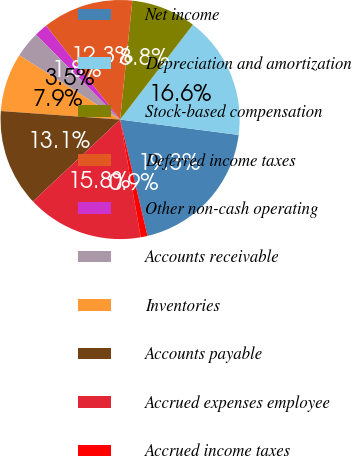Convert chart to OTSL. <chart><loc_0><loc_0><loc_500><loc_500><pie_chart><fcel>Net income<fcel>Depreciation and amortization<fcel>Stock-based compensation<fcel>Deferred income taxes<fcel>Other non-cash operating<fcel>Accounts receivable<fcel>Inventories<fcel>Accounts payable<fcel>Accrued expenses employee<fcel>Accrued income taxes<nl><fcel>19.26%<fcel>16.64%<fcel>8.78%<fcel>12.27%<fcel>1.79%<fcel>3.54%<fcel>7.9%<fcel>13.14%<fcel>15.76%<fcel>0.92%<nl></chart> 